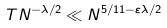<formula> <loc_0><loc_0><loc_500><loc_500>T N ^ { - \lambda / 2 } \ll N ^ { 5 / 1 1 - \varepsilon \lambda / 2 }</formula> 